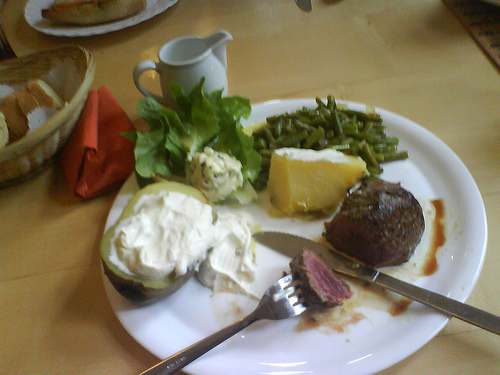<image>
Is there a cup on the plate? No. The cup is not positioned on the plate. They may be near each other, but the cup is not supported by or resting on top of the plate. 